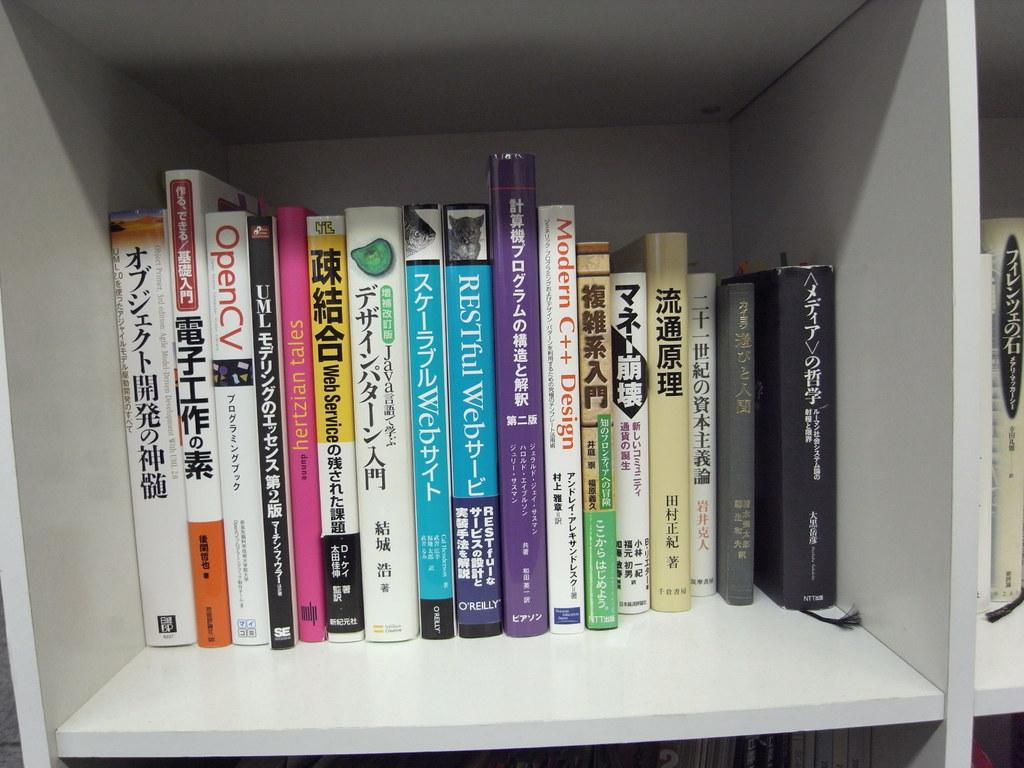<image>
Write a terse but informative summary of the picture. A row of books in Asian text including OpenCV. 